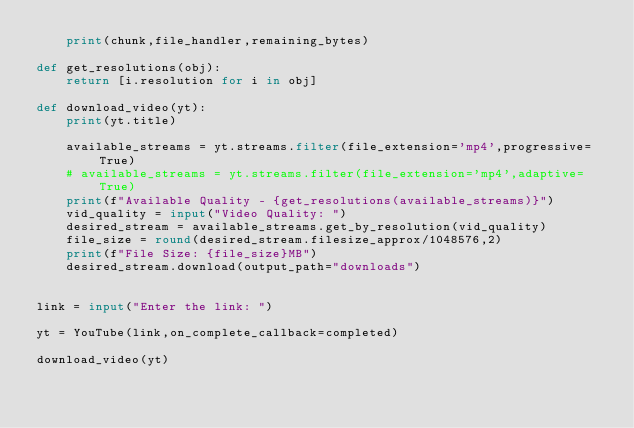<code> <loc_0><loc_0><loc_500><loc_500><_Python_>    print(chunk,file_handler,remaining_bytes)

def get_resolutions(obj):
    return [i.resolution for i in obj]

def download_video(yt):
    print(yt.title)

    available_streams = yt.streams.filter(file_extension='mp4',progressive=True)
    # available_streams = yt.streams.filter(file_extension='mp4',adaptive=True)
    print(f"Available Quality - {get_resolutions(available_streams)}")
    vid_quality = input("Video Quality: ")
    desired_stream = available_streams.get_by_resolution(vid_quality)
    file_size = round(desired_stream.filesize_approx/1048576,2)
    print(f"File Size: {file_size}MB")
    desired_stream.download(output_path="downloads")


link = input("Enter the link: ")

yt = YouTube(link,on_complete_callback=completed)

download_video(yt)



</code> 